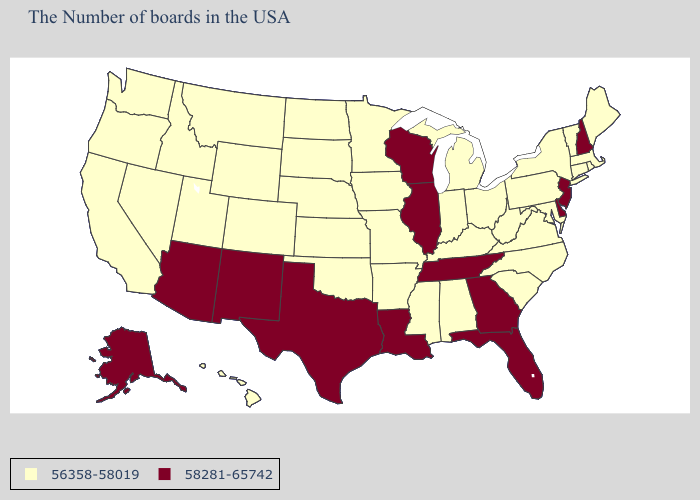Which states have the lowest value in the USA?
Concise answer only. Maine, Massachusetts, Rhode Island, Vermont, Connecticut, New York, Maryland, Pennsylvania, Virginia, North Carolina, South Carolina, West Virginia, Ohio, Michigan, Kentucky, Indiana, Alabama, Mississippi, Missouri, Arkansas, Minnesota, Iowa, Kansas, Nebraska, Oklahoma, South Dakota, North Dakota, Wyoming, Colorado, Utah, Montana, Idaho, Nevada, California, Washington, Oregon, Hawaii. What is the lowest value in states that border Utah?
Concise answer only. 56358-58019. Among the states that border New Hampshire , which have the lowest value?
Short answer required. Maine, Massachusetts, Vermont. What is the value of North Dakota?
Give a very brief answer. 56358-58019. Among the states that border Arkansas , does Louisiana have the lowest value?
Give a very brief answer. No. Among the states that border Maryland , which have the highest value?
Give a very brief answer. Delaware. What is the highest value in states that border Missouri?
Keep it brief. 58281-65742. Does the first symbol in the legend represent the smallest category?
Short answer required. Yes. Does Wisconsin have the same value as Texas?
Write a very short answer. Yes. What is the lowest value in the West?
Be succinct. 56358-58019. How many symbols are there in the legend?
Keep it brief. 2. Does Idaho have the same value as Utah?
Be succinct. Yes. Name the states that have a value in the range 58281-65742?
Short answer required. New Hampshire, New Jersey, Delaware, Florida, Georgia, Tennessee, Wisconsin, Illinois, Louisiana, Texas, New Mexico, Arizona, Alaska. What is the value of Nevada?
Answer briefly. 56358-58019. Does Minnesota have a lower value than Maine?
Write a very short answer. No. 